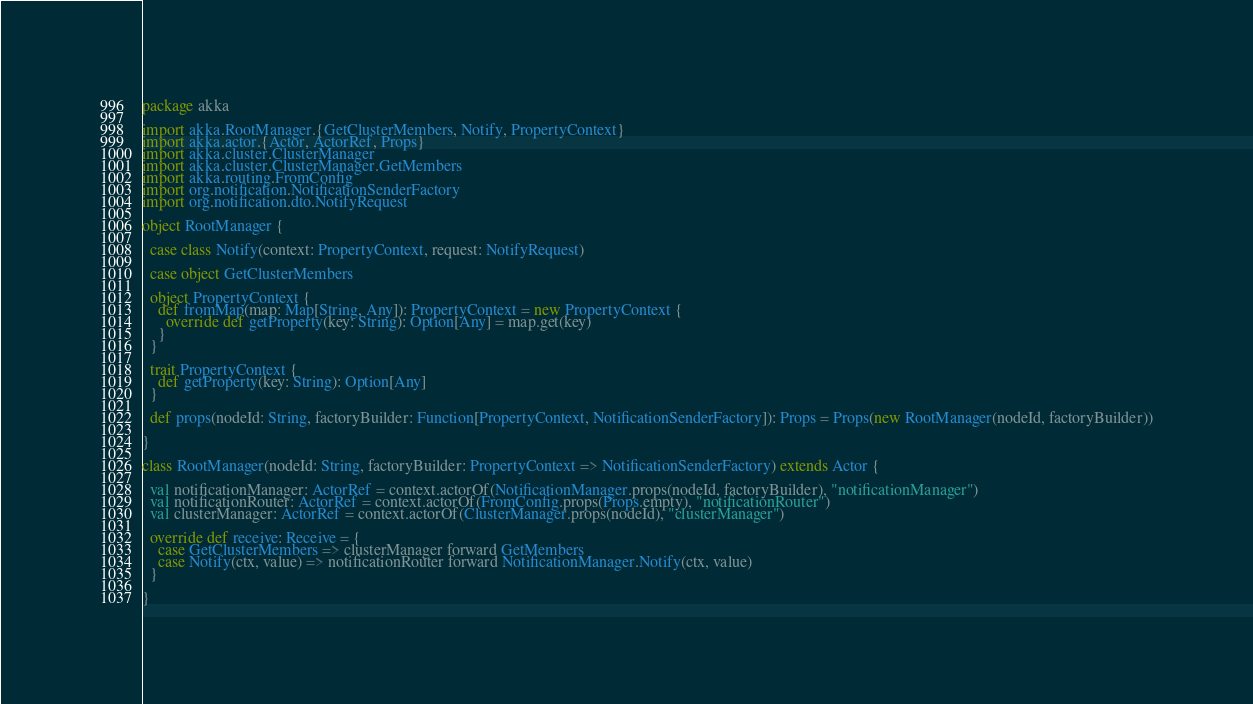<code> <loc_0><loc_0><loc_500><loc_500><_Scala_>package akka

import akka.RootManager.{GetClusterMembers, Notify, PropertyContext}
import akka.actor.{Actor, ActorRef, Props}
import akka.cluster.ClusterManager
import akka.cluster.ClusterManager.GetMembers
import akka.routing.FromConfig
import org.notification.NotificationSenderFactory
import org.notification.dto.NotifyRequest

object RootManager {

  case class Notify(context: PropertyContext, request: NotifyRequest)

  case object GetClusterMembers

  object PropertyContext {
    def fromMap(map: Map[String, Any]): PropertyContext = new PropertyContext {
      override def getProperty(key: String): Option[Any] = map.get(key)
    }
  }

  trait PropertyContext {
    def getProperty(key: String): Option[Any]
  }

  def props(nodeId: String, factoryBuilder: Function[PropertyContext, NotificationSenderFactory]): Props = Props(new RootManager(nodeId, factoryBuilder))

}

class RootManager(nodeId: String, factoryBuilder: PropertyContext => NotificationSenderFactory) extends Actor {

  val notificationManager: ActorRef = context.actorOf(NotificationManager.props(nodeId, factoryBuilder), "notificationManager")
  val notificationRouter: ActorRef = context.actorOf(FromConfig.props(Props.empty), "notificationRouter")
  val clusterManager: ActorRef = context.actorOf(ClusterManager.props(nodeId), "clusterManager")

  override def receive: Receive = {
    case GetClusterMembers => clusterManager forward GetMembers
    case Notify(ctx, value) => notificationRouter forward NotificationManager.Notify(ctx, value)
  }

}</code> 